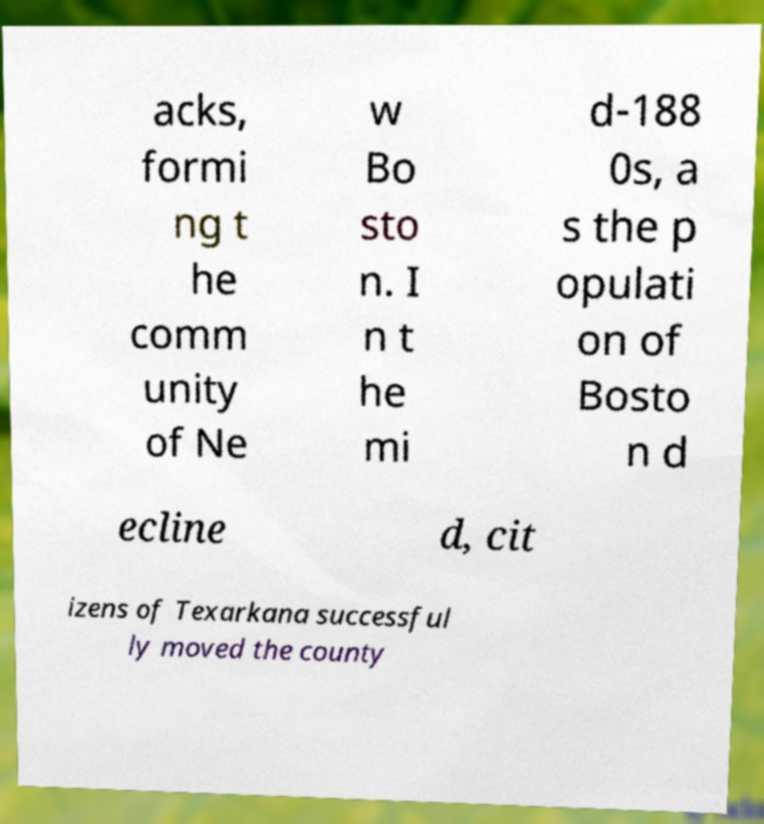Could you assist in decoding the text presented in this image and type it out clearly? acks, formi ng t he comm unity of Ne w Bo sto n. I n t he mi d-188 0s, a s the p opulati on of Bosto n d ecline d, cit izens of Texarkana successful ly moved the county 